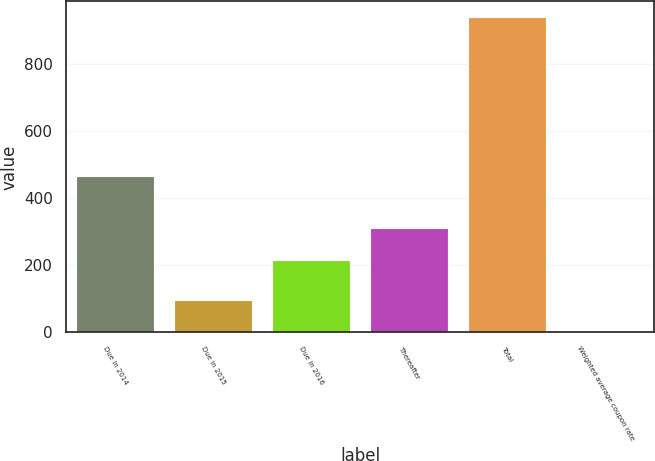Convert chart. <chart><loc_0><loc_0><loc_500><loc_500><bar_chart><fcel>Due in 2014<fcel>Due in 2015<fcel>Due in 2016<fcel>Thereafter<fcel>Total<fcel>Weighted average coupon rate<nl><fcel>466<fcel>96.16<fcel>216<fcel>309.76<fcel>940<fcel>2.4<nl></chart> 